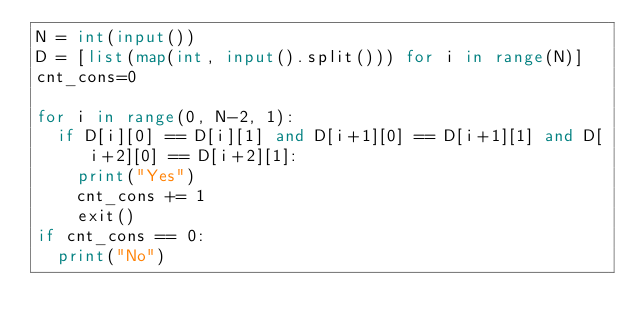<code> <loc_0><loc_0><loc_500><loc_500><_Python_>N = int(input())
D = [list(map(int, input().split())) for i in range(N)]
cnt_cons=0

for i in range(0, N-2, 1):
  if D[i][0] == D[i][1] and D[i+1][0] == D[i+1][1] and D[i+2][0] == D[i+2][1]:
    print("Yes")
    cnt_cons += 1
    exit()
if cnt_cons == 0:
  print("No")</code> 